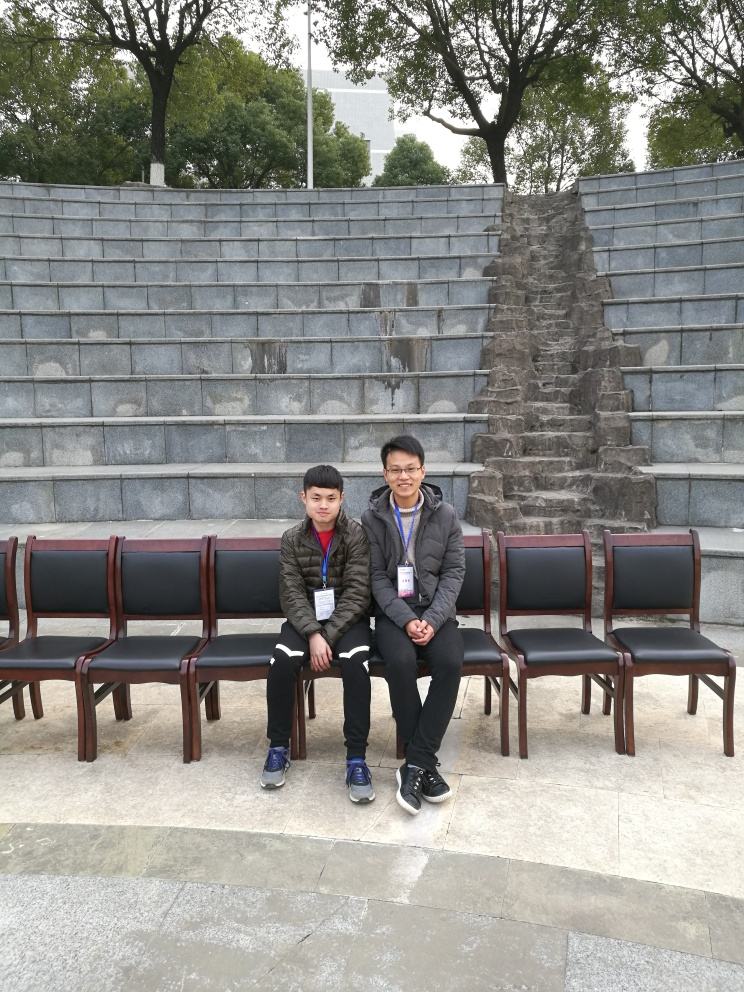If you could imagine a story behind this image, what would it be? One might imagine a story of two friends or colleagues taking a moment to rest, perhaps during a break from a nearby event or conference, reflecting on the day's activities in a moment of shared solitude amidst the quiet grandeur of the setting. 